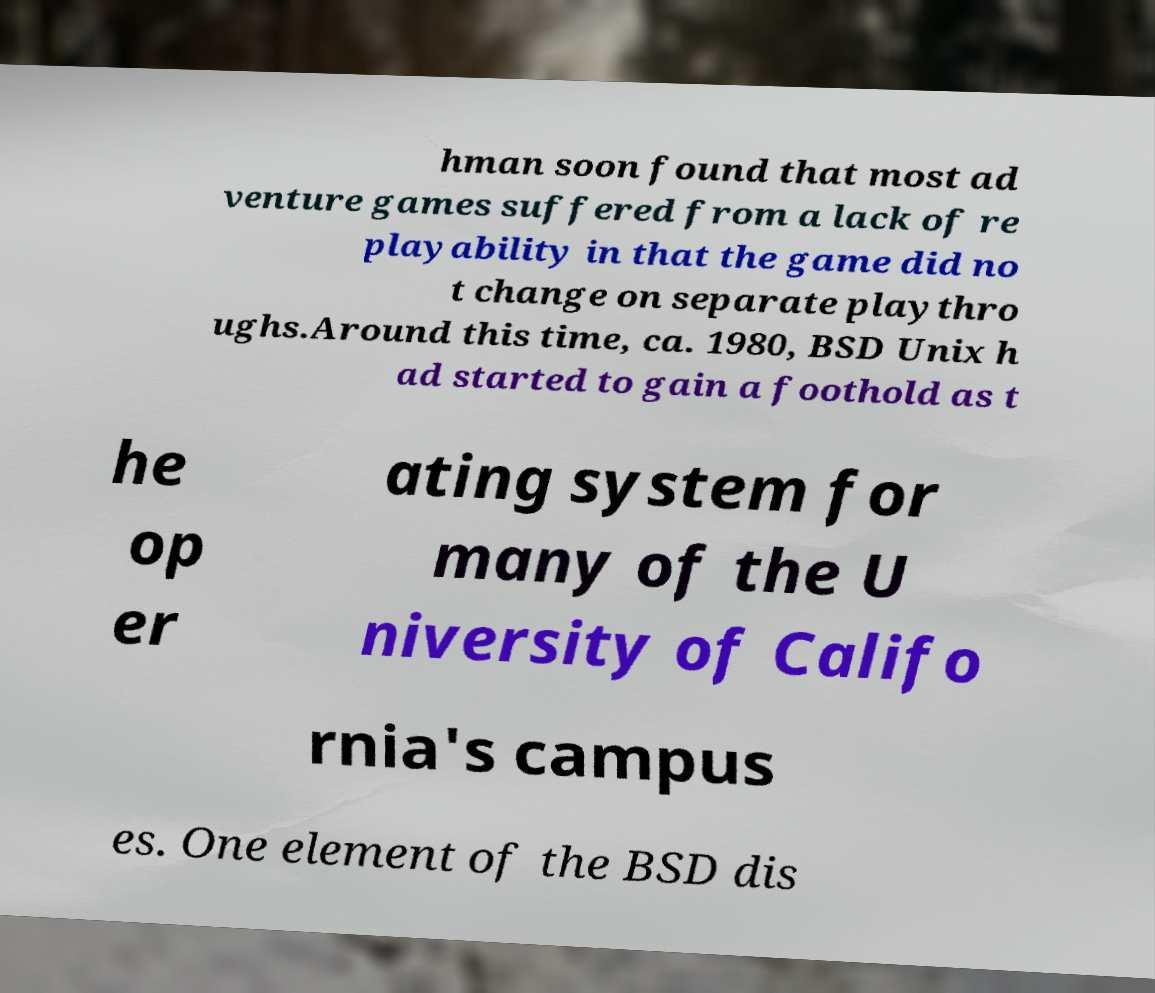Please identify and transcribe the text found in this image. hman soon found that most ad venture games suffered from a lack of re playability in that the game did no t change on separate playthro ughs.Around this time, ca. 1980, BSD Unix h ad started to gain a foothold as t he op er ating system for many of the U niversity of Califo rnia's campus es. One element of the BSD dis 